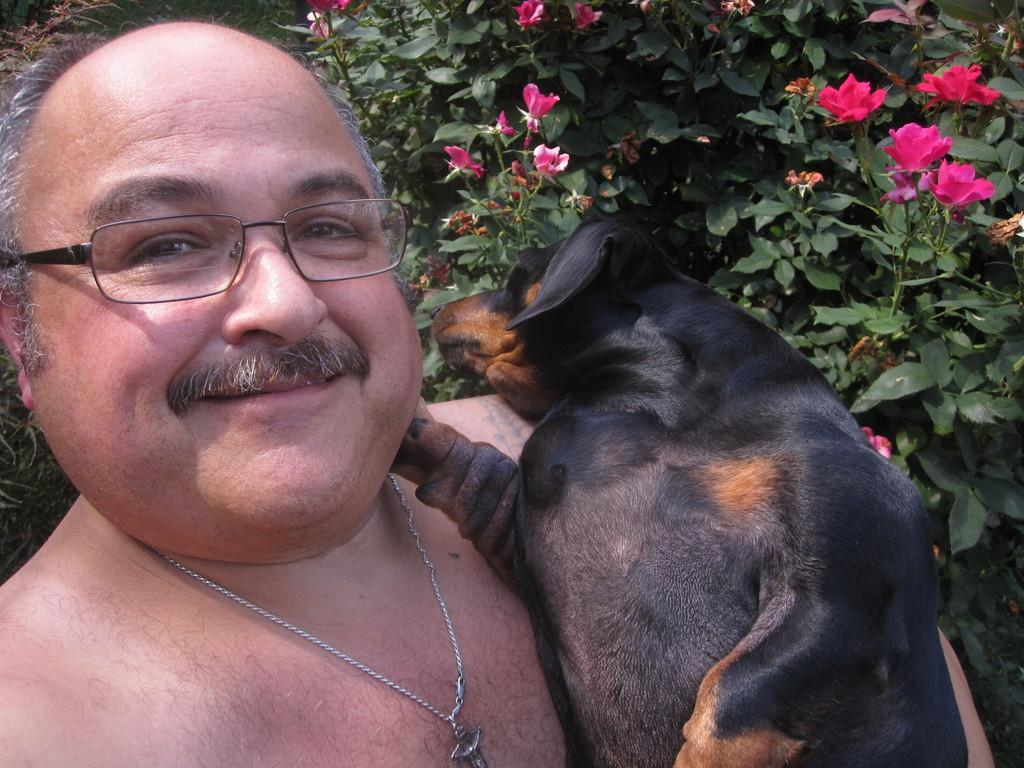Who is present in the image? There is a man in the image. What is the man holding? The man is holding a dog. What else can be seen in the image besides the man and the dog? There are plants in the image. What type of alarm can be heard going off in the image? There is no alarm present in the image, so it cannot be heard. 